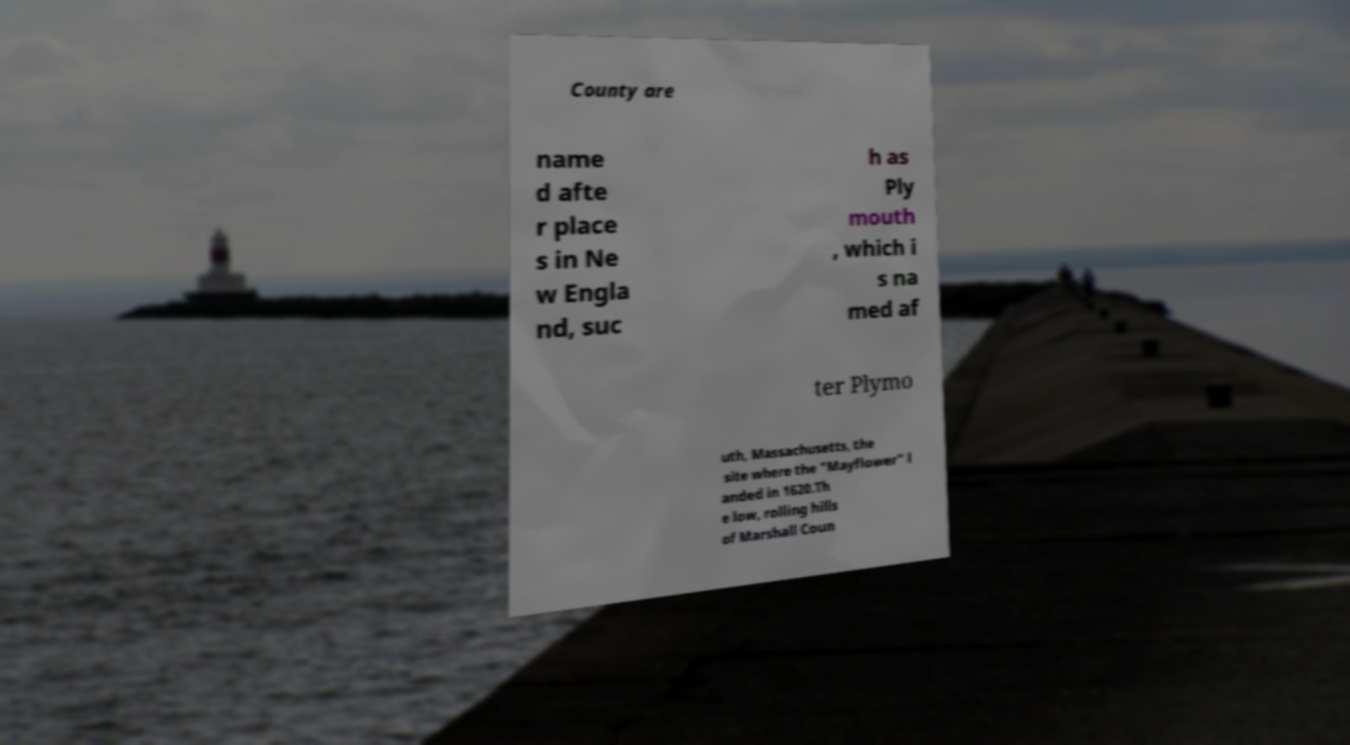Can you accurately transcribe the text from the provided image for me? County are name d afte r place s in Ne w Engla nd, suc h as Ply mouth , which i s na med af ter Plymo uth, Massachusetts, the site where the "Mayflower" l anded in 1620.Th e low, rolling hills of Marshall Coun 